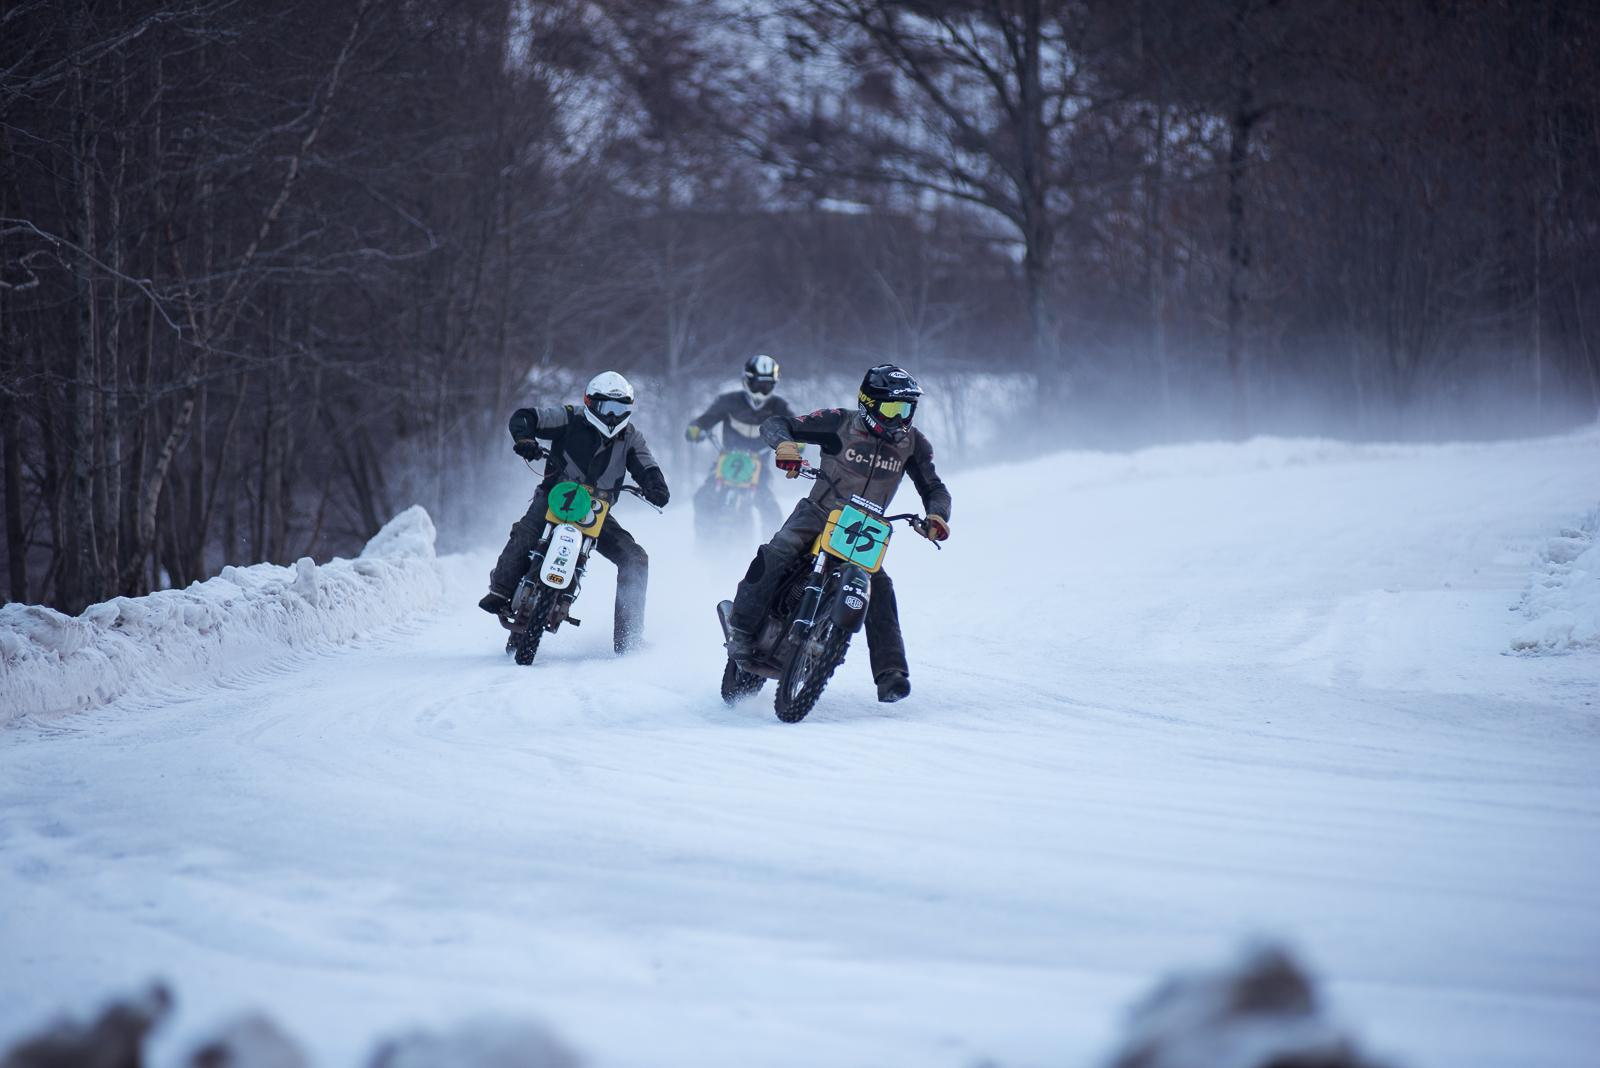Describe the modifications that might be made to these motorbikes for this environment. Modifications for riding in snowy conditions often include fitting the motorbikes with studded tires for better grip, adjusting the suspension settings to handle the uneven terrain, and preparing the engine for cold-weather starts. Riders may also apply protective film to prevent ice buildup on surfaces. 